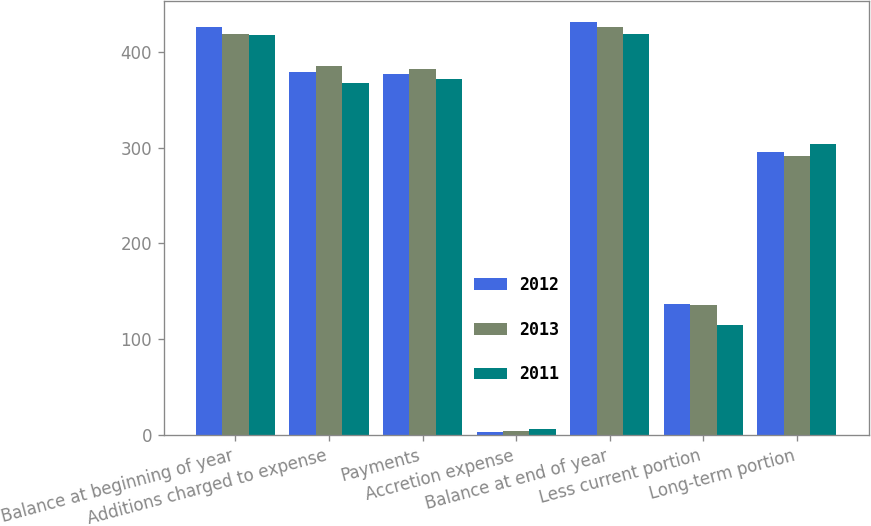<chart> <loc_0><loc_0><loc_500><loc_500><stacked_bar_chart><ecel><fcel>Balance at beginning of year<fcel>Additions charged to expense<fcel>Payments<fcel>Accretion expense<fcel>Balance at end of year<fcel>Less current portion<fcel>Long-term portion<nl><fcel>2012<fcel>426.4<fcel>379.1<fcel>377.2<fcel>3.2<fcel>431.5<fcel>136.6<fcel>294.9<nl><fcel>2013<fcel>418.3<fcel>385.5<fcel>381.6<fcel>4.2<fcel>426.4<fcel>135.5<fcel>290.9<nl><fcel>2011<fcel>417.2<fcel>367.3<fcel>372.1<fcel>5.9<fcel>418.3<fcel>114.4<fcel>303.9<nl></chart> 